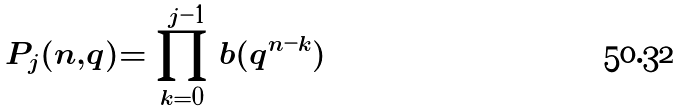<formula> <loc_0><loc_0><loc_500><loc_500>P _ { j } ( n , q ) = \prod _ { k = 0 } ^ { j - 1 } b ( q ^ { n - k } )</formula> 